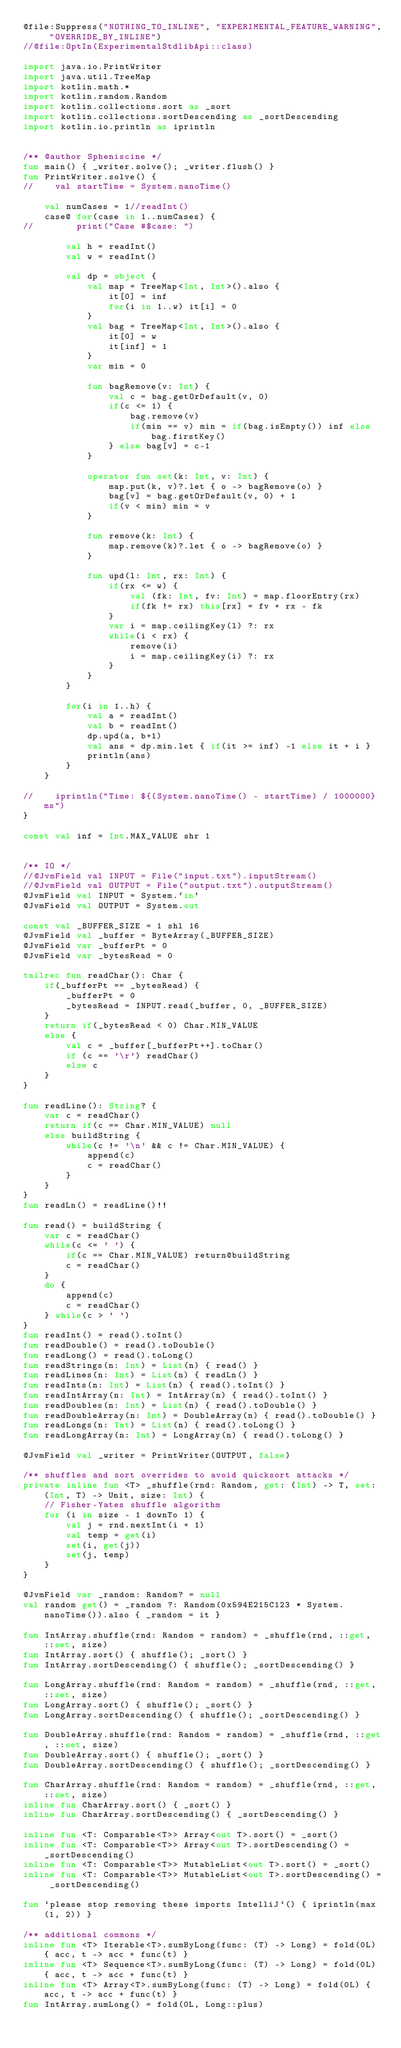Convert code to text. <code><loc_0><loc_0><loc_500><loc_500><_Kotlin_>@file:Suppress("NOTHING_TO_INLINE", "EXPERIMENTAL_FEATURE_WARNING", "OVERRIDE_BY_INLINE")
//@file:OptIn(ExperimentalStdlibApi::class)

import java.io.PrintWriter
import java.util.TreeMap
import kotlin.math.*
import kotlin.random.Random
import kotlin.collections.sort as _sort
import kotlin.collections.sortDescending as _sortDescending
import kotlin.io.println as iprintln


/** @author Spheniscine */
fun main() { _writer.solve(); _writer.flush() }
fun PrintWriter.solve() {
//    val startTime = System.nanoTime()

    val numCases = 1//readInt()
    case@ for(case in 1..numCases) {
//        print("Case #$case: ")

        val h = readInt()
        val w = readInt()

        val dp = object {
            val map = TreeMap<Int, Int>().also {
                it[0] = inf
                for(i in 1..w) it[i] = 0
            }
            val bag = TreeMap<Int, Int>().also {
                it[0] = w
                it[inf] = 1
            }
            var min = 0

            fun bagRemove(v: Int) {
                val c = bag.getOrDefault(v, 0)
                if(c <= 1) {
                    bag.remove(v)
                    if(min == v) min = if(bag.isEmpty()) inf else bag.firstKey()
                } else bag[v] = c-1
            }

            operator fun set(k: Int, v: Int) {
                map.put(k, v)?.let { o -> bagRemove(o) }
                bag[v] = bag.getOrDefault(v, 0) + 1
                if(v < min) min = v
            }

            fun remove(k: Int) {
                map.remove(k)?.let { o -> bagRemove(o) }
            }

            fun upd(l: Int, rx: Int) {
                if(rx <= w) {
                    val (fk: Int, fv: Int) = map.floorEntry(rx)
                    if(fk != rx) this[rx] = fv + rx - fk
                }
                var i = map.ceilingKey(l) ?: rx
                while(i < rx) {
                    remove(i)
                    i = map.ceilingKey(i) ?: rx
                }
            }
        }

        for(i in 1..h) {
            val a = readInt()
            val b = readInt()
            dp.upd(a, b+1)
            val ans = dp.min.let { if(it >= inf) -1 else it + i }
            println(ans)
        }
    }

//    iprintln("Time: ${(System.nanoTime() - startTime) / 1000000} ms")
}

const val inf = Int.MAX_VALUE shr 1


/** IO */
//@JvmField val INPUT = File("input.txt").inputStream()
//@JvmField val OUTPUT = File("output.txt").outputStream()
@JvmField val INPUT = System.`in`
@JvmField val OUTPUT = System.out

const val _BUFFER_SIZE = 1 shl 16
@JvmField val _buffer = ByteArray(_BUFFER_SIZE)
@JvmField var _bufferPt = 0
@JvmField var _bytesRead = 0

tailrec fun readChar(): Char {
    if(_bufferPt == _bytesRead) {
        _bufferPt = 0
        _bytesRead = INPUT.read(_buffer, 0, _BUFFER_SIZE)
    }
    return if(_bytesRead < 0) Char.MIN_VALUE
    else {
        val c = _buffer[_bufferPt++].toChar()
        if (c == '\r') readChar()
        else c
    }
}

fun readLine(): String? {
    var c = readChar()
    return if(c == Char.MIN_VALUE) null
    else buildString {
        while(c != '\n' && c != Char.MIN_VALUE) {
            append(c)
            c = readChar()
        }
    }
}
fun readLn() = readLine()!!

fun read() = buildString {
    var c = readChar()
    while(c <= ' ') {
        if(c == Char.MIN_VALUE) return@buildString
        c = readChar()
    }
    do {
        append(c)
        c = readChar()
    } while(c > ' ')
}
fun readInt() = read().toInt()
fun readDouble() = read().toDouble()
fun readLong() = read().toLong()
fun readStrings(n: Int) = List(n) { read() }
fun readLines(n: Int) = List(n) { readLn() }
fun readInts(n: Int) = List(n) { read().toInt() }
fun readIntArray(n: Int) = IntArray(n) { read().toInt() }
fun readDoubles(n: Int) = List(n) { read().toDouble() }
fun readDoubleArray(n: Int) = DoubleArray(n) { read().toDouble() }
fun readLongs(n: Int) = List(n) { read().toLong() }
fun readLongArray(n: Int) = LongArray(n) { read().toLong() }

@JvmField val _writer = PrintWriter(OUTPUT, false)

/** shuffles and sort overrides to avoid quicksort attacks */
private inline fun <T> _shuffle(rnd: Random, get: (Int) -> T, set: (Int, T) -> Unit, size: Int) {
    // Fisher-Yates shuffle algorithm
    for (i in size - 1 downTo 1) {
        val j = rnd.nextInt(i + 1)
        val temp = get(i)
        set(i, get(j))
        set(j, temp)
    }
}

@JvmField var _random: Random? = null
val random get() = _random ?: Random(0x594E215C123 * System.nanoTime()).also { _random = it }

fun IntArray.shuffle(rnd: Random = random) = _shuffle(rnd, ::get, ::set, size)
fun IntArray.sort() { shuffle(); _sort() }
fun IntArray.sortDescending() { shuffle(); _sortDescending() }

fun LongArray.shuffle(rnd: Random = random) = _shuffle(rnd, ::get, ::set, size)
fun LongArray.sort() { shuffle(); _sort() }
fun LongArray.sortDescending() { shuffle(); _sortDescending() }

fun DoubleArray.shuffle(rnd: Random = random) = _shuffle(rnd, ::get, ::set, size)
fun DoubleArray.sort() { shuffle(); _sort() }
fun DoubleArray.sortDescending() { shuffle(); _sortDescending() }

fun CharArray.shuffle(rnd: Random = random) = _shuffle(rnd, ::get, ::set, size)
inline fun CharArray.sort() { _sort() }
inline fun CharArray.sortDescending() { _sortDescending() }

inline fun <T: Comparable<T>> Array<out T>.sort() = _sort()
inline fun <T: Comparable<T>> Array<out T>.sortDescending() = _sortDescending()
inline fun <T: Comparable<T>> MutableList<out T>.sort() = _sort()
inline fun <T: Comparable<T>> MutableList<out T>.sortDescending() = _sortDescending()

fun `please stop removing these imports IntelliJ`() { iprintln(max(1, 2)) }

/** additional commons */
inline fun <T> Iterable<T>.sumByLong(func: (T) -> Long) = fold(0L) { acc, t -> acc + func(t) }
inline fun <T> Sequence<T>.sumByLong(func: (T) -> Long) = fold(0L) { acc, t -> acc + func(t) }
inline fun <T> Array<T>.sumByLong(func: (T) -> Long) = fold(0L) { acc, t -> acc + func(t) }
fun IntArray.sumLong() = fold(0L, Long::plus)
</code> 